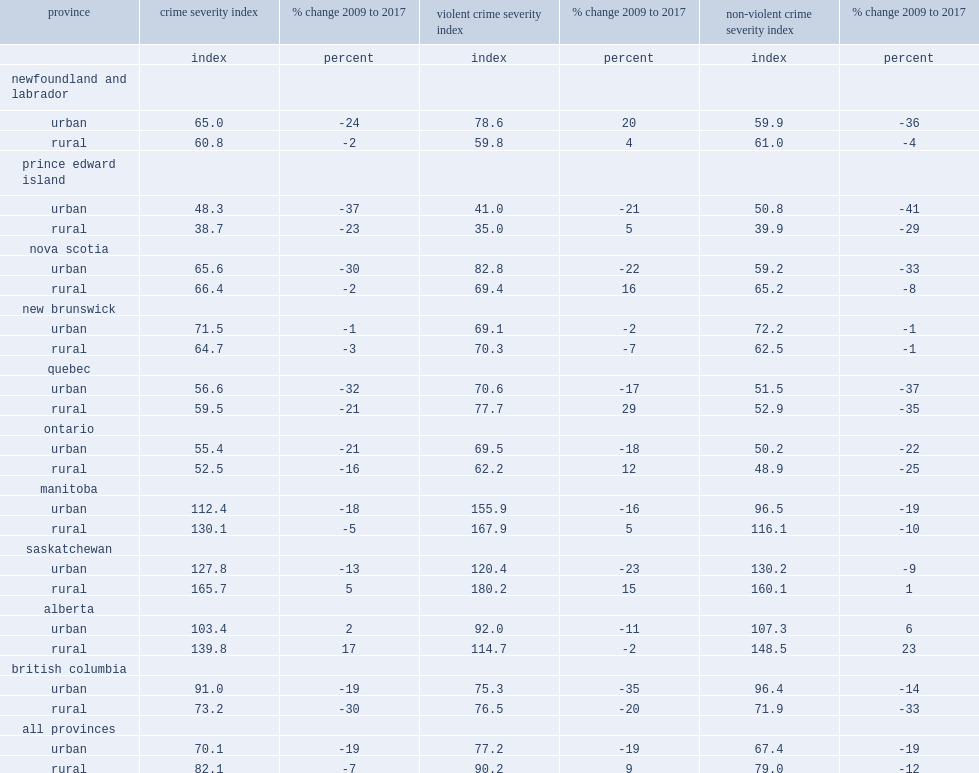What were the percent changes in the csi from 2009 in rural alberta and saskatchewan ? 17.0 5.0. 